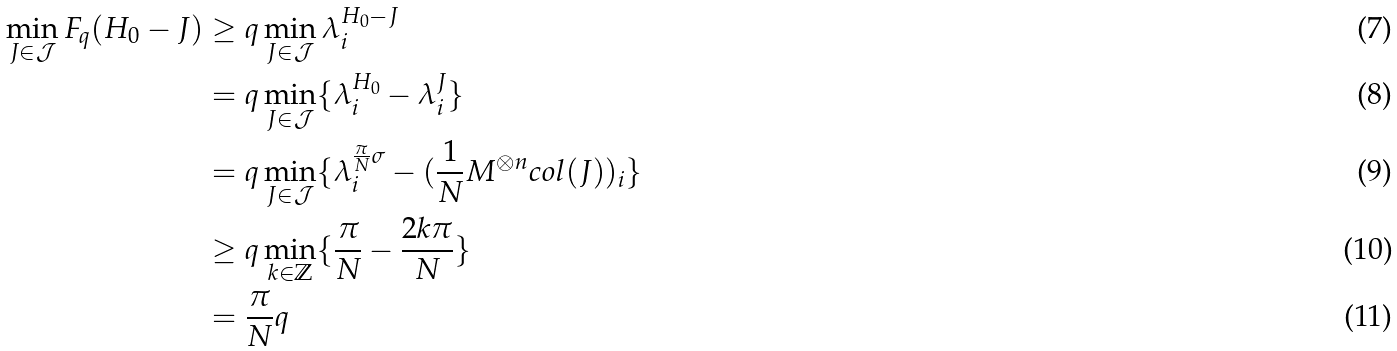Convert formula to latex. <formula><loc_0><loc_0><loc_500><loc_500>\min _ { J \in \mathcal { J } } F _ { q } ( H _ { 0 } - J ) & \geq q \min _ { J \in \mathcal { J } } \lambda ^ { H _ { 0 } - J } _ { i } \\ & = q \min _ { J \in \mathcal { J } } \{ \lambda ^ { H _ { 0 } } _ { i } - \lambda ^ { J } _ { i } \} \\ & = q \min _ { J \in \mathcal { J } } \{ \lambda ^ { \frac { \pi } { N } \sigma } _ { i } - ( \frac { 1 } { N } M ^ { \otimes n } c o l ( J ) ) _ { i } \} \\ & \geq q \min _ { k \in \mathbb { Z } } \{ \frac { \pi } { N } - \frac { 2 k \pi } { N } \} \\ & = \frac { \pi } { N } q</formula> 